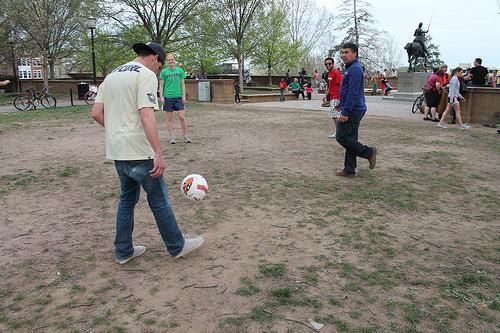How many people are kicking the ball?
Give a very brief answer. 4. 